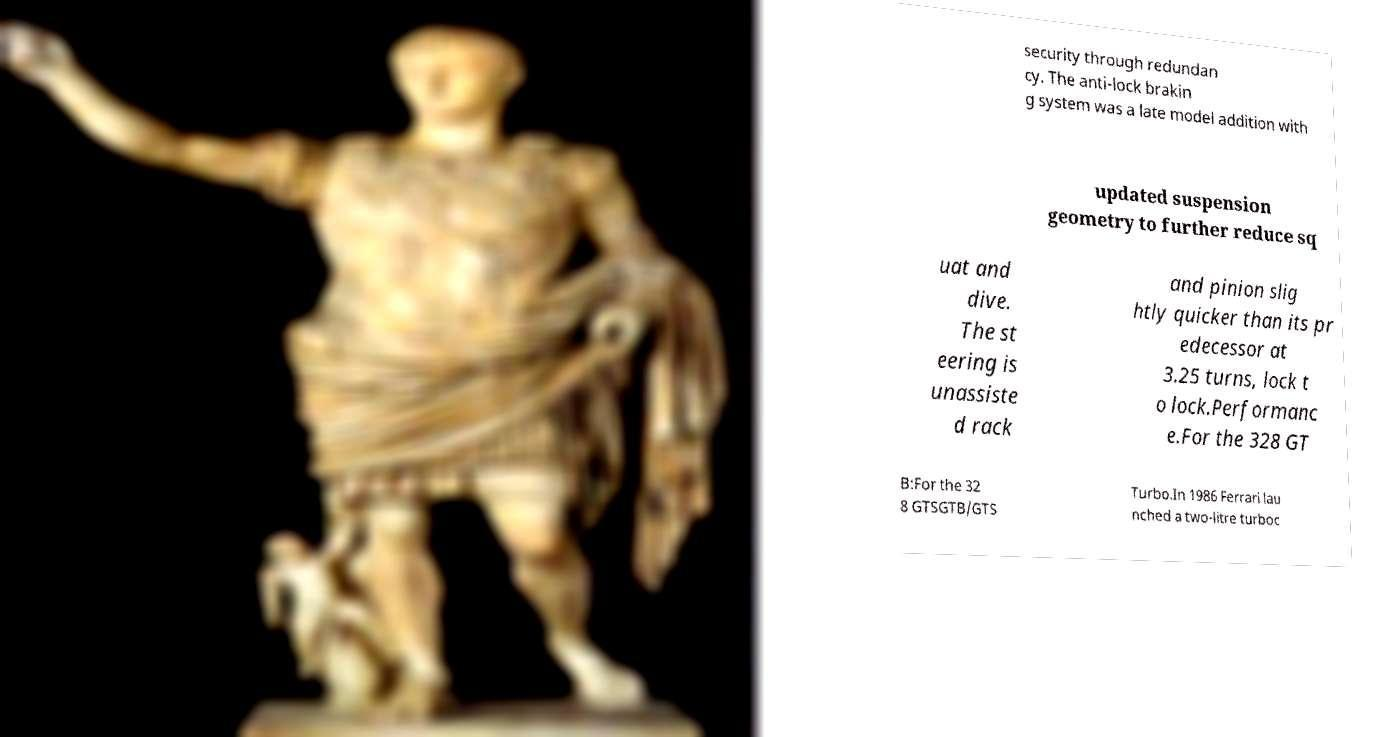For documentation purposes, I need the text within this image transcribed. Could you provide that? security through redundan cy. The anti-lock brakin g system was a late model addition with updated suspension geometry to further reduce sq uat and dive. The st eering is unassiste d rack and pinion slig htly quicker than its pr edecessor at 3.25 turns, lock t o lock.Performanc e.For the 328 GT B:For the 32 8 GTSGTB/GTS Turbo.In 1986 Ferrari lau nched a two-litre turboc 